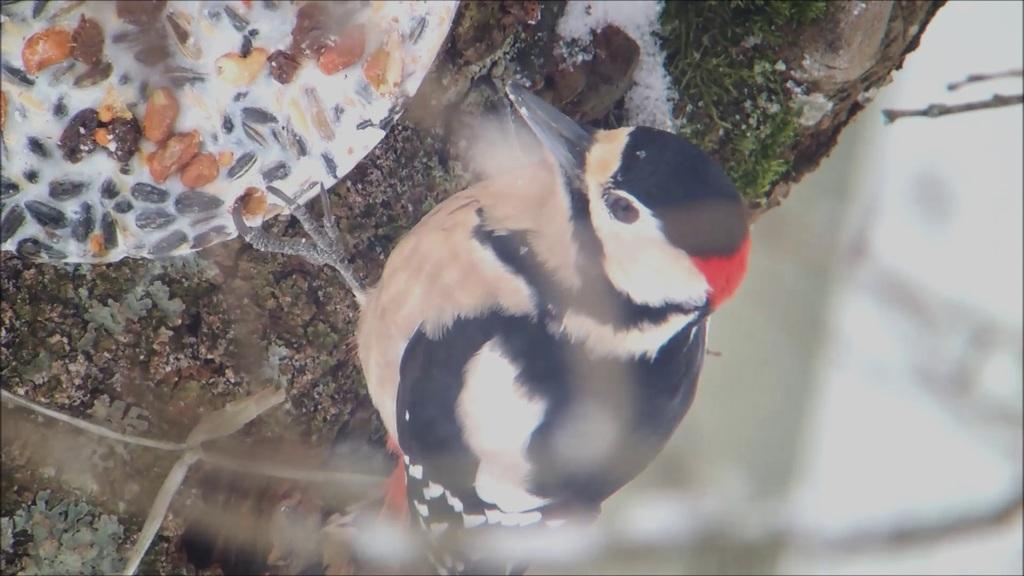What type of animal can be seen in the image? There is a bird in the image. Where is the bird located? The bird is on a tree. Can you describe the bird's appearance? The bird has multiple colors. How many lizards can be seen in the image? There are no lizards present in the image; it features a bird on a tree. What type of wilderness can be seen in the image? The image does not depict a specific wilderness area; it simply shows a bird on a tree. 